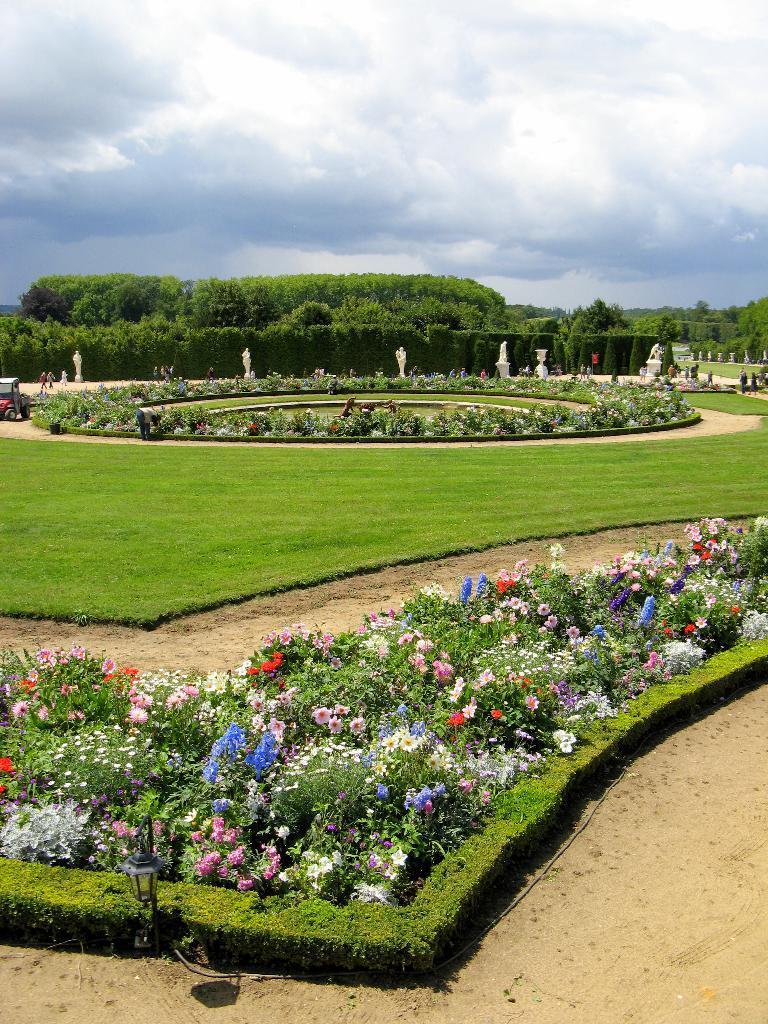How would you summarize this image in a sentence or two? In this image there are plants and grass on the ground. There are flowers to the plants. In the background there are hedges and trees. To the left there is a vehicle on the ground. To the right there are a few people. At the top there is the sky. 